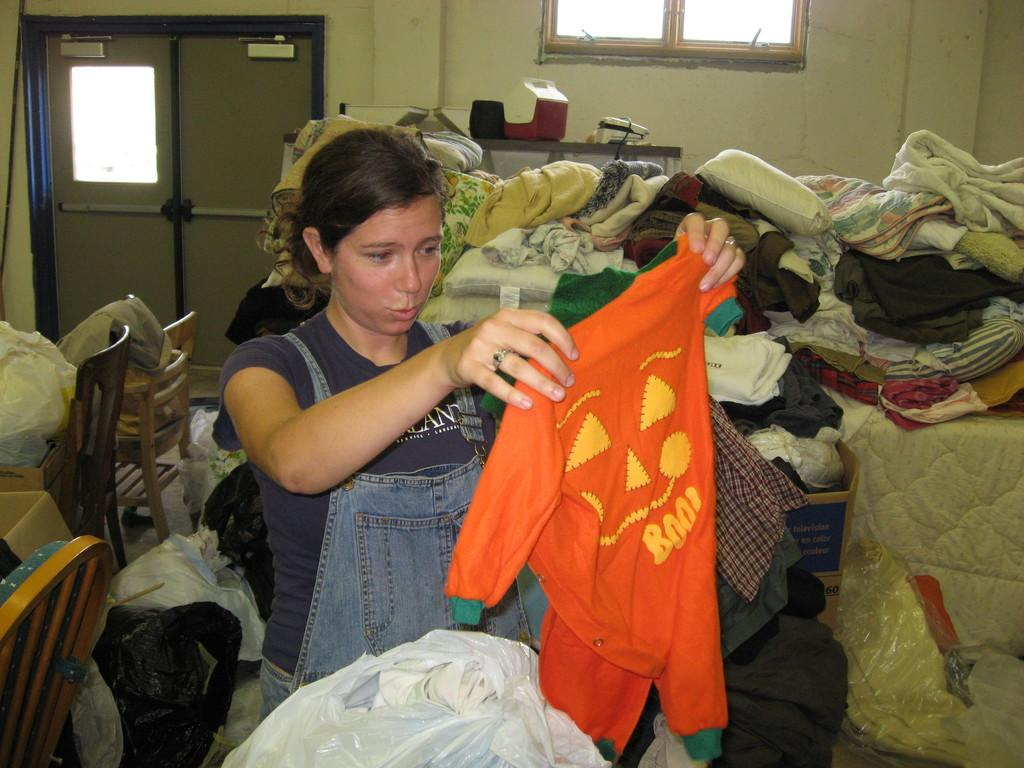What is the person in the image holding? The person in the image is holding a cloth. What can be seen on the bed in the image? There are clothes on the bed in the image. What type of furniture is present in the room? There are chairs in the room. What is used to cover items in the room? There are covers in the room. What feature allows natural light into the room? There is a window in the room. What type of beef is being served at the secretary's desk in the image? There is no secretary or beef present in the image. 